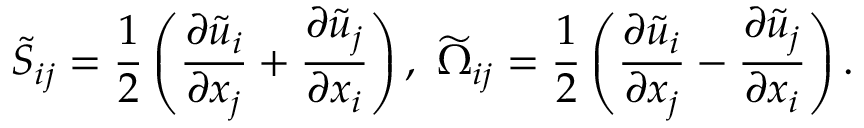<formula> <loc_0><loc_0><loc_500><loc_500>{ \widetilde { S } } _ { i j } = \frac { 1 } { 2 } \left ( { \frac { \partial { \widetilde { u } } _ { i } } { \partial x _ { j } } + \frac { \partial { \widetilde { u } } _ { j } } { \partial x _ { i } } } \right ) , { \widetilde { \Omega } } _ { i j } = \frac { 1 } { 2 } \left ( { \frac { \partial { \widetilde { u } } _ { i } } { \partial x _ { j } } - \frac { \partial { \widetilde { u } } _ { j } } { \partial x _ { i } } } \right ) .</formula> 